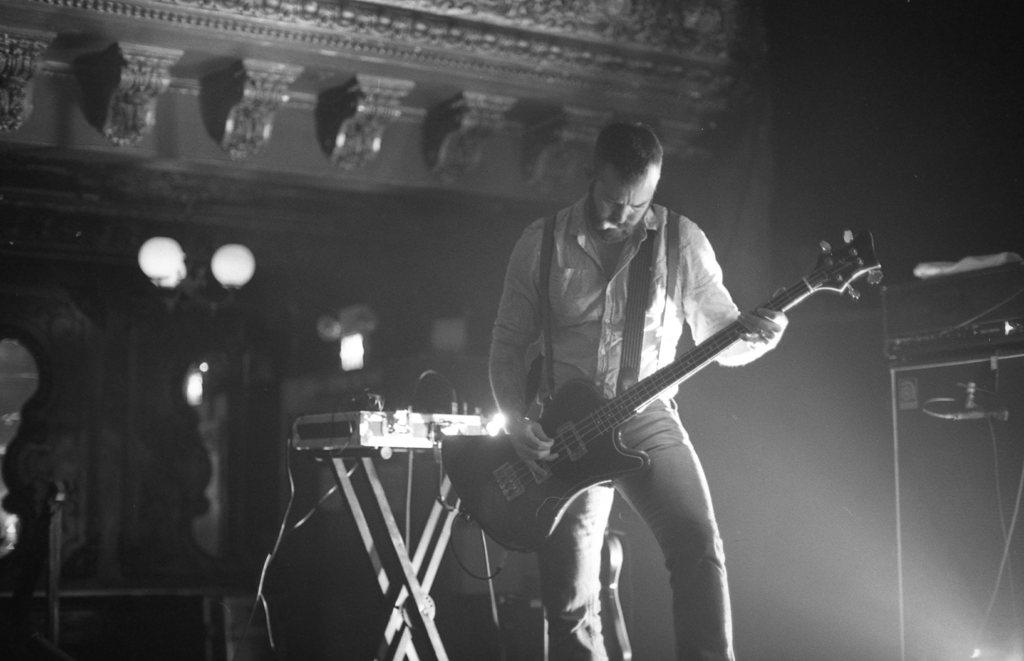Who is the main subject in the image? There is a man in the center of the image. What is the man doing in the image? The man is playing a guitar. Are there any other musical instruments visible in the image? Yes, there are musical instruments visible in the image. Where is the plate with the egg located in the image? There is no plate or egg present in the image. Can you tell me which country the map in the image is depicting? There is no map present in the image. 